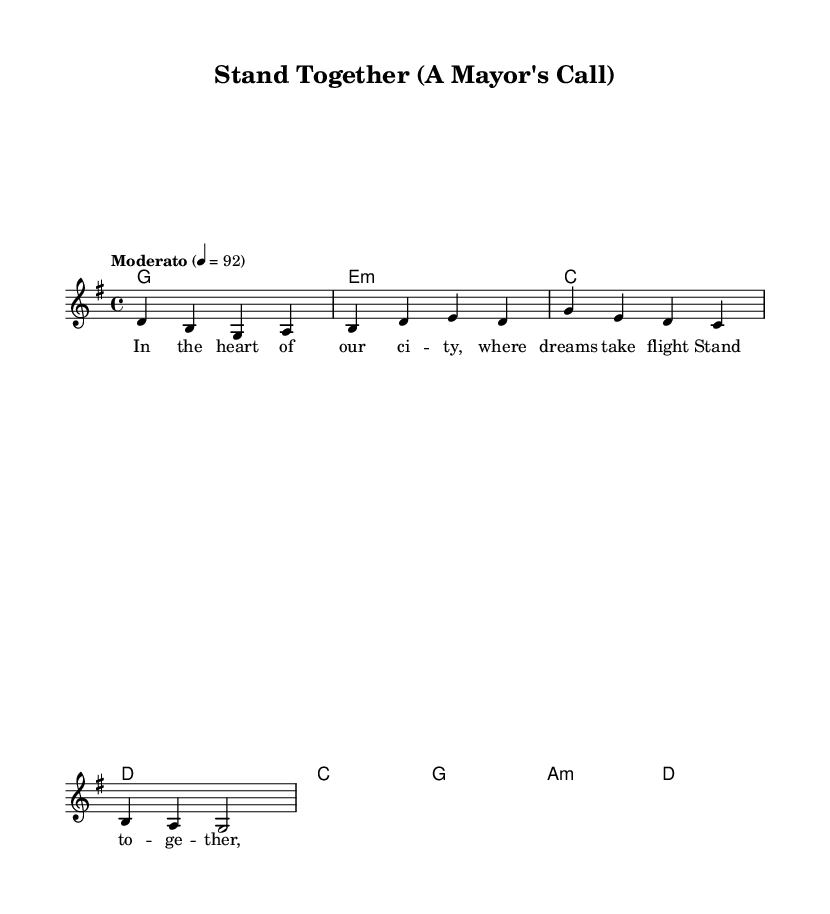What is the key signature of this music? The key signature indicated at the beginning of the score shows that the music is in G major, which has one sharp (F#).
Answer: G major What is the time signature of this piece? The time signature is notated at the beginning of the score as 4/4, meaning there are four beats in each measure and the quarter note gets one beat.
Answer: 4/4 What tempo is indicated for this score? The score indicates a tempo marking of "Moderato" with a metronome marking of 92, suggesting a moderate speed.
Answer: Moderato How many lines are present in the melody staff? The staff shown in the score has five lines, which is standard for treble clef notation.
Answer: Five What is the first chord in the verse? The first chord in the verse is notated as G major, which corresponds to the first measure of the harmonies.
Answer: G How does the chorus contrast with the verse in terms of chords? The verse uses four different chords (G, E minor, C, D), while the chorus also has four but differs by using G, A minor, and D, indicating a shift in harmony.
Answer: Different chords What lyrical theme is reflected in the title "Stand Together"? The title suggests themes of unity and community engagement, which directly ties into the lyrics emphasizing collective action and civic responsibility.
Answer: Unity 